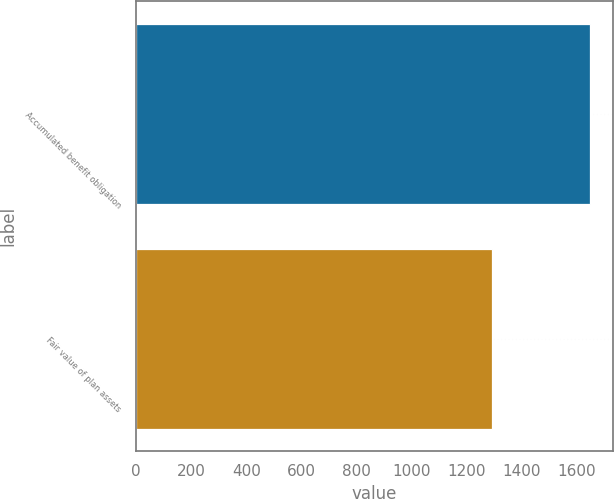<chart> <loc_0><loc_0><loc_500><loc_500><bar_chart><fcel>Accumulated benefit obligation<fcel>Fair value of plan assets<nl><fcel>1648.9<fcel>1292.6<nl></chart> 